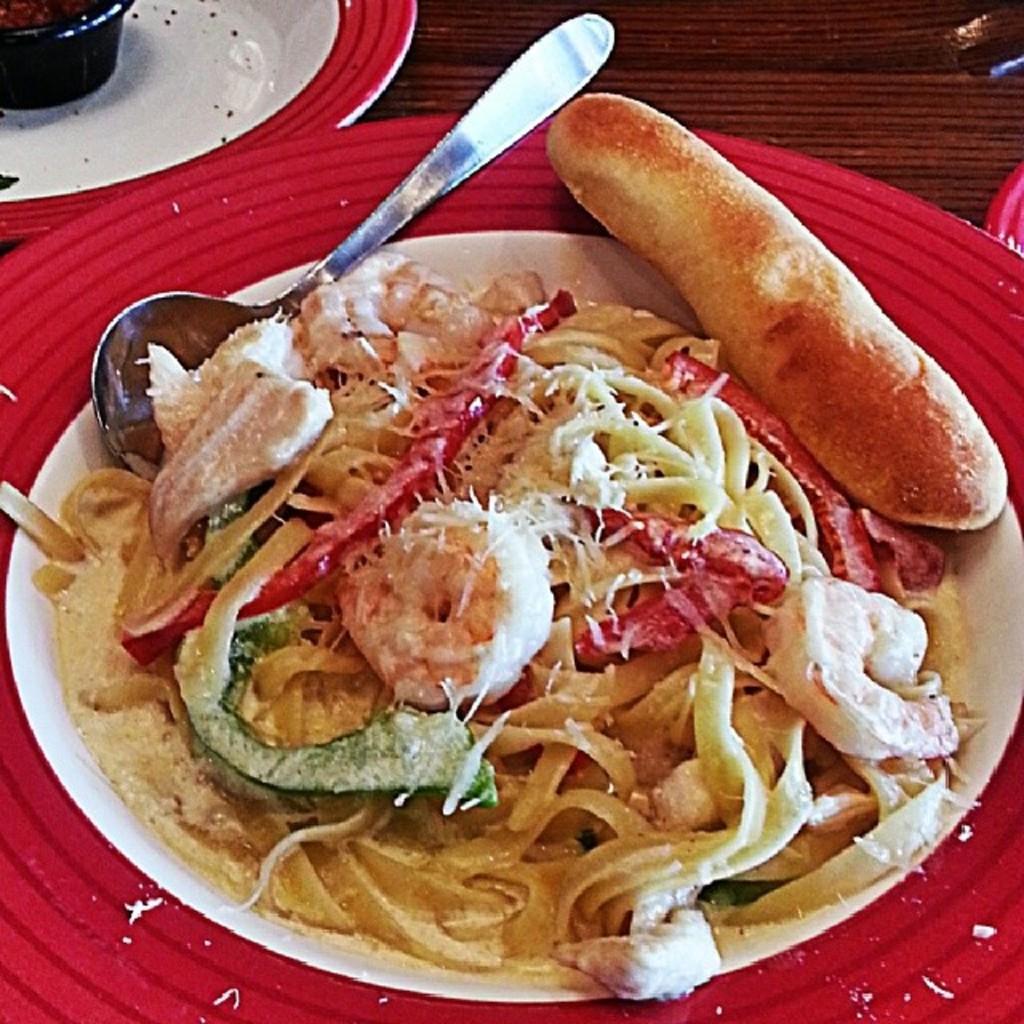Could you give a brief overview of what you see in this image? In this image there are two plates on a wooden surface. In the center there is a spoon on the plate. There is food on the plate. In the food there are green bell peppers, red bell peppers, spaghetti, prawns, bread and grated cheese. 